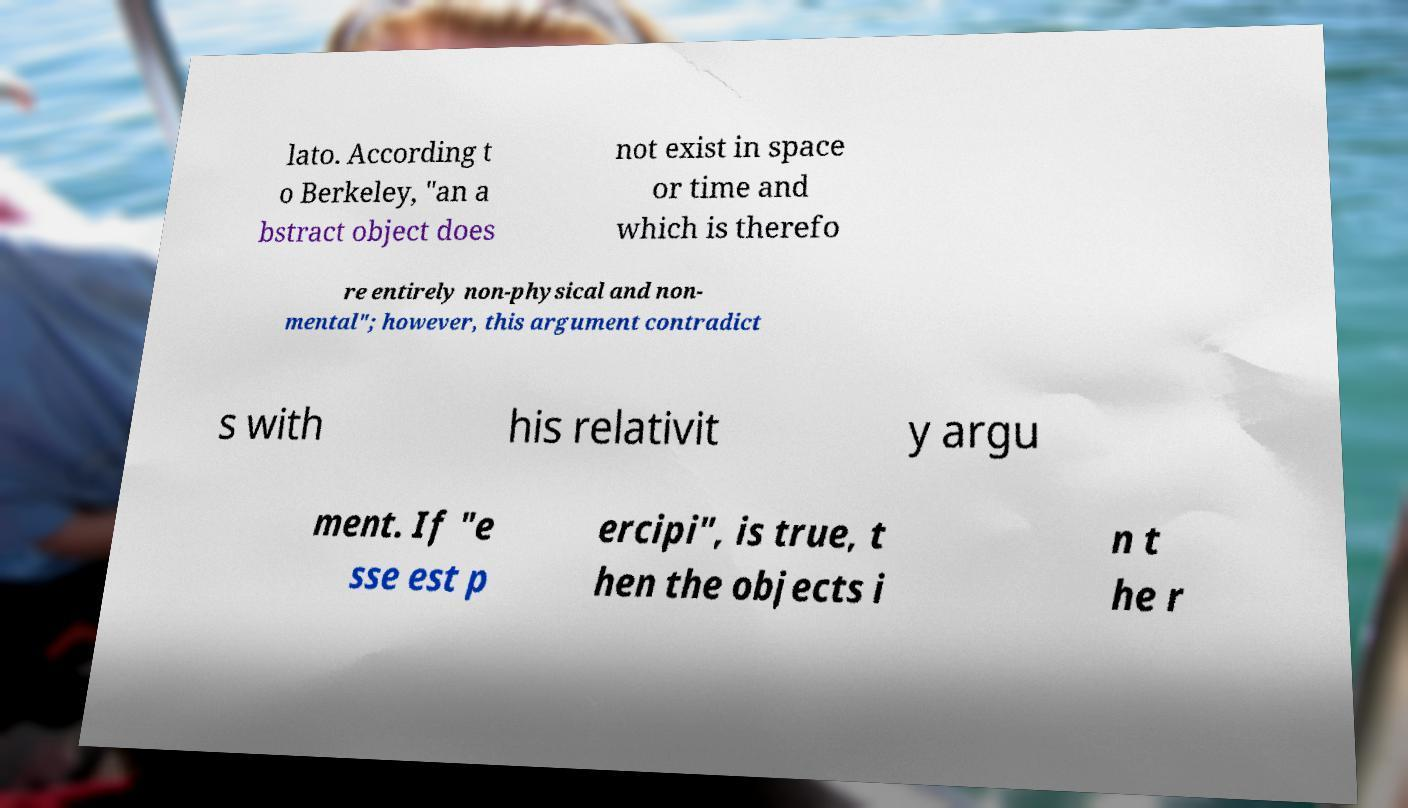Please identify and transcribe the text found in this image. lato. According t o Berkeley, "an a bstract object does not exist in space or time and which is therefo re entirely non-physical and non- mental"; however, this argument contradict s with his relativit y argu ment. If "e sse est p ercipi", is true, t hen the objects i n t he r 